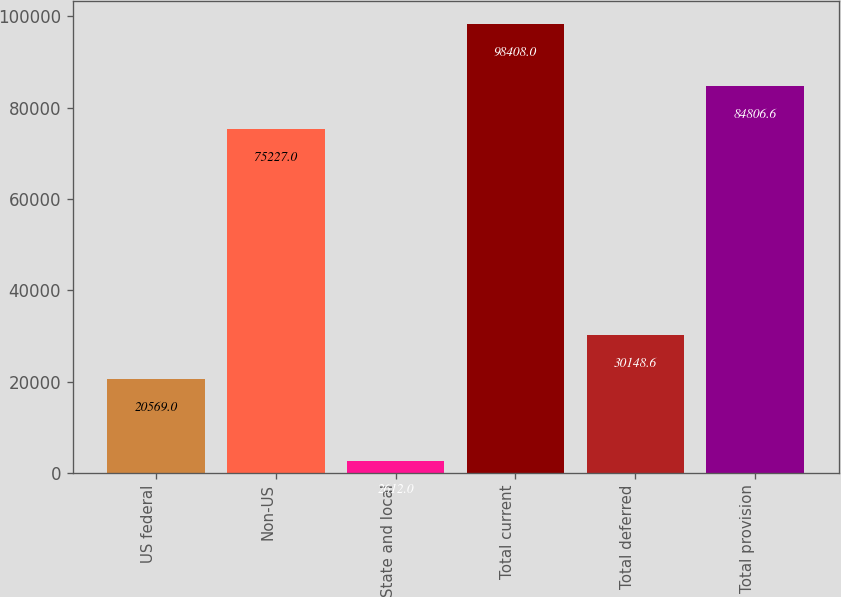Convert chart to OTSL. <chart><loc_0><loc_0><loc_500><loc_500><bar_chart><fcel>US federal<fcel>Non-US<fcel>State and local<fcel>Total current<fcel>Total deferred<fcel>Total provision<nl><fcel>20569<fcel>75227<fcel>2612<fcel>98408<fcel>30148.6<fcel>84806.6<nl></chart> 